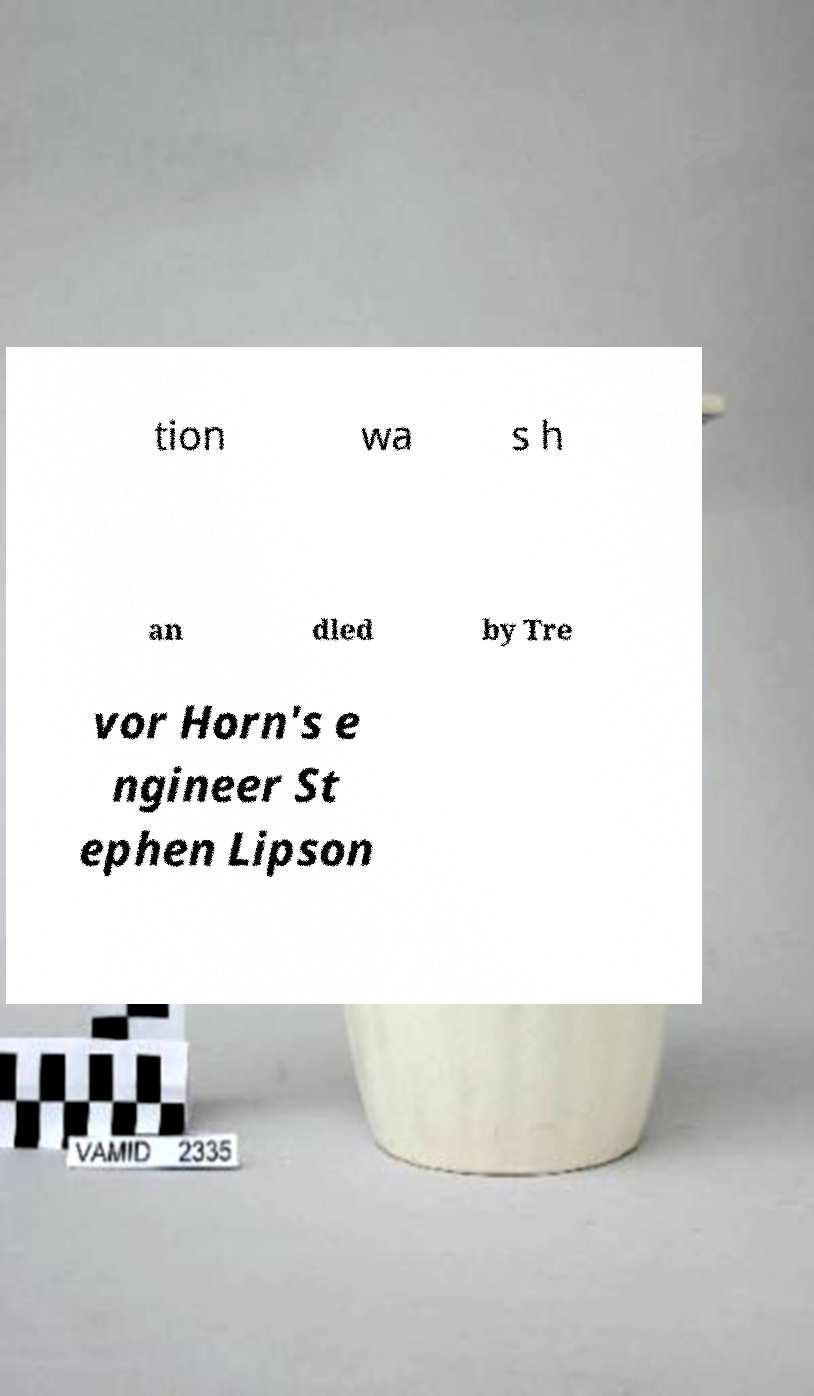What messages or text are displayed in this image? I need them in a readable, typed format. tion wa s h an dled by Tre vor Horn's e ngineer St ephen Lipson 